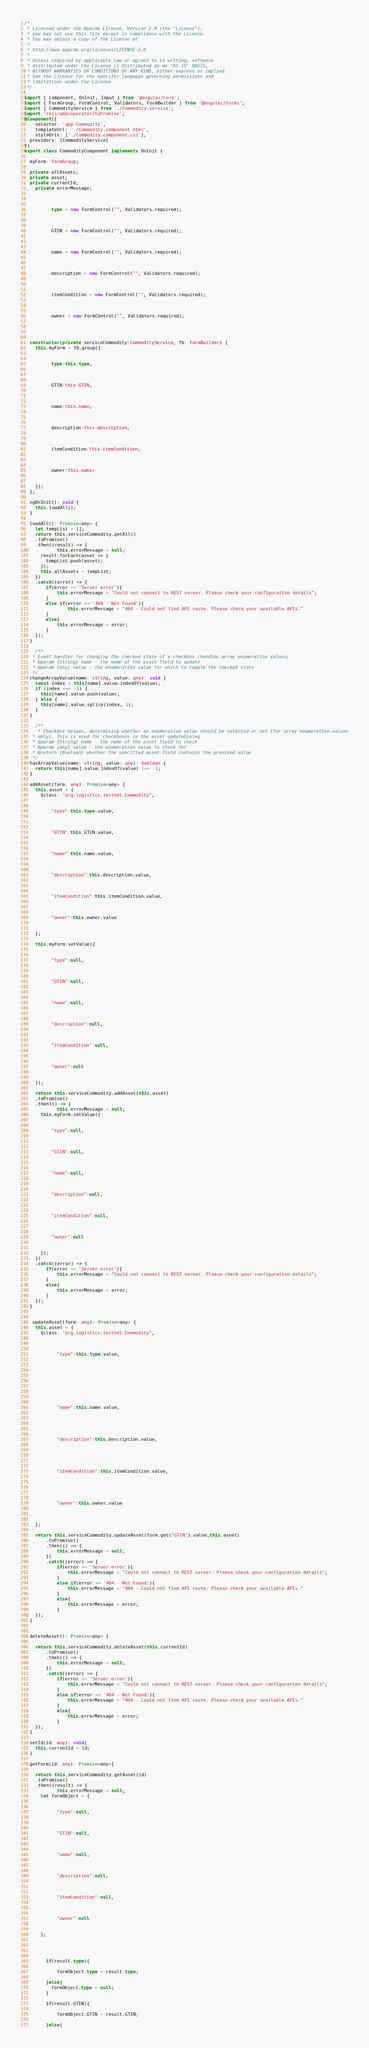<code> <loc_0><loc_0><loc_500><loc_500><_TypeScript_>/*
 * Licensed under the Apache License, Version 2.0 (the "License");
 * you may not use this file except in compliance with the License.
 * You may obtain a copy of the License at
 *
 * http://www.apache.org/licenses/LICENSE-2.0
 *
 * Unless required by applicable law or agreed to in writing, software
 * distributed under the License is distributed on an "AS IS" BASIS,
 * WITHOUT WARRANTIES OR CONDITIONS OF ANY KIND, either express or implied.
 * See the License for the specific language governing permissions and
 * limitations under the License.
 */

import { Component, OnInit, Input } from '@angular/core';
import { FormGroup, FormControl, Validators, FormBuilder } from '@angular/forms';
import { CommodityService } from './Commodity.service';
import 'rxjs/add/operator/toPromise';
@Component({
	selector: 'app-Commodity',
	templateUrl: './Commodity.component.html',
	styleUrls: ['./Commodity.component.css'],
  providers: [CommodityService]
})
export class CommodityComponent implements OnInit {

  myForm: FormGroup;

  private allAssets;
  private asset;
  private currentId;
	private errorMessage;

  
      
          type = new FormControl("", Validators.required);
        
  
      
          GTIN = new FormControl("", Validators.required);
        
  
      
          name = new FormControl("", Validators.required);
        
  
      
          description = new FormControl("", Validators.required);
        
  
      
          itemCondition = new FormControl("", Validators.required);
        
  
      
          owner = new FormControl("", Validators.required);
        
  


  constructor(private serviceCommodity:CommodityService, fb: FormBuilder) {
    this.myForm = fb.group({
    
        
          type:this.type,
        
    
        
          GTIN:this.GTIN,
        
    
        
          name:this.name,
        
    
        
          description:this.description,
        
    
        
          itemCondition:this.itemCondition,
        
    
        
          owner:this.owner
        
    
    });
  };

  ngOnInit(): void {
    this.loadAll();
  }

  loadAll(): Promise<any> {
    let tempList = [];
    return this.serviceCommodity.getAll()
    .toPromise()
    .then((result) => {
			this.errorMessage = null;
      result.forEach(asset => {
        tempList.push(asset);
      });
      this.allAssets = tempList;
    })
    .catch((error) => {
        if(error == 'Server error'){
            this.errorMessage = "Could not connect to REST server. Please check your configuration details";
        }
        else if(error == '404 - Not Found'){
				this.errorMessage = "404 - Could not find API route. Please check your available APIs."
        }
        else{
            this.errorMessage = error;
        }
    });
  }

	/**
   * Event handler for changing the checked state of a checkbox (handles array enumeration values)
   * @param {String} name - the name of the asset field to update
   * @param {any} value - the enumeration value for which to toggle the checked state
   */
  changeArrayValue(name: string, value: any): void {
    const index = this[name].value.indexOf(value);
    if (index === -1) {
      this[name].value.push(value);
    } else {
      this[name].value.splice(index, 1);
    }
  }

	/**
	 * Checkbox helper, determining whether an enumeration value should be selected or not (for array enumeration values
   * only). This is used for checkboxes in the asset updateDialog.
   * @param {String} name - the name of the asset field to check
   * @param {any} value - the enumeration value to check for
   * @return {Boolean} whether the specified asset field contains the provided value
   */
  hasArrayValue(name: string, value: any): boolean {
    return this[name].value.indexOf(value) !== -1;
  }

  addAsset(form: any): Promise<any> {
    this.asset = {
      $class: "org.logistics.testnet.Commodity",
      
        
          "type":this.type.value,
        
      
        
          "GTIN":this.GTIN.value,
        
      
        
          "name":this.name.value,
        
      
        
          "description":this.description.value,
        
      
        
          "itemCondition":this.itemCondition.value,
        
      
        
          "owner":this.owner.value
        
      
    };

    this.myForm.setValue({
      
        
          "type":null,
        
      
        
          "GTIN":null,
        
      
        
          "name":null,
        
      
        
          "description":null,
        
      
        
          "itemCondition":null,
        
      
        
          "owner":null
        
      
    });

    return this.serviceCommodity.addAsset(this.asset)
    .toPromise()
    .then(() => {
			this.errorMessage = null;
      this.myForm.setValue({
      
        
          "type":null,
        
      
        
          "GTIN":null,
        
      
        
          "name":null,
        
      
        
          "description":null,
        
      
        
          "itemCondition":null,
        
      
        
          "owner":null 
        
      
      });
    })
    .catch((error) => {
        if(error == 'Server error'){
            this.errorMessage = "Could not connect to REST server. Please check your configuration details";
        }
        else{
            this.errorMessage = error;
        }
    });
  }


   updateAsset(form: any): Promise<any> {
    this.asset = {
      $class: "org.logistics.testnet.Commodity",
      
        
          
            "type":this.type.value,
          
        
    
        
          
        
    
        
          
            "name":this.name.value,
          
        
    
        
          
            "description":this.description.value,
          
        
    
        
          
            "itemCondition":this.itemCondition.value,
          
        
    
        
          
            "owner":this.owner.value
          
        
    
    };

    return this.serviceCommodity.updateAsset(form.get("GTIN").value,this.asset)
		.toPromise()
		.then(() => {
			this.errorMessage = null;
		})
		.catch((error) => {
            if(error == 'Server error'){
				this.errorMessage = "Could not connect to REST server. Please check your configuration details";
			}
            else if(error == '404 - Not Found'){
				this.errorMessage = "404 - Could not find API route. Please check your available APIs."
			}
			else{
				this.errorMessage = error;
			}
    });
  }


  deleteAsset(): Promise<any> {

    return this.serviceCommodity.deleteAsset(this.currentId)
		.toPromise()
		.then(() => {
			this.errorMessage = null;
		})
		.catch((error) => {
            if(error == 'Server error'){
				this.errorMessage = "Could not connect to REST server. Please check your configuration details";
			}
			else if(error == '404 - Not Found'){
				this.errorMessage = "404 - Could not find API route. Please check your available APIs."
			}
			else{
				this.errorMessage = error;
			}
    });
  }

  setId(id: any): void{
    this.currentId = id;
  }

  getForm(id: any): Promise<any>{

    return this.serviceCommodity.getAsset(id)
    .toPromise()
    .then((result) => {
			this.errorMessage = null;
      let formObject = {
        
          
            "type":null,
          
        
          
            "GTIN":null,
          
        
          
            "name":null,
          
        
          
            "description":null,
          
        
          
            "itemCondition":null,
          
        
          
            "owner":null 
          
        
      };



      
        if(result.type){
          
            formObject.type = result.type;
          
        }else{
          formObject.type = null;
        }
      
        if(result.GTIN){
          
            formObject.GTIN = result.GTIN;
          
        }else{</code> 